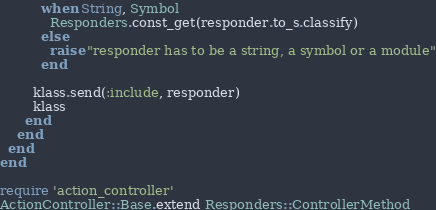Convert code to text. <code><loc_0><loc_0><loc_500><loc_500><_Ruby_>          when String, Symbol
            Responders.const_get(responder.to_s.classify)
          else
            raise "responder has to be a string, a symbol or a module"
          end

        klass.send(:include, responder)
        klass
      end
    end
  end
end

require 'action_controller'
ActionController::Base.extend Responders::ControllerMethod
</code> 